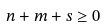Convert formula to latex. <formula><loc_0><loc_0><loc_500><loc_500>n + m + s \geq 0</formula> 